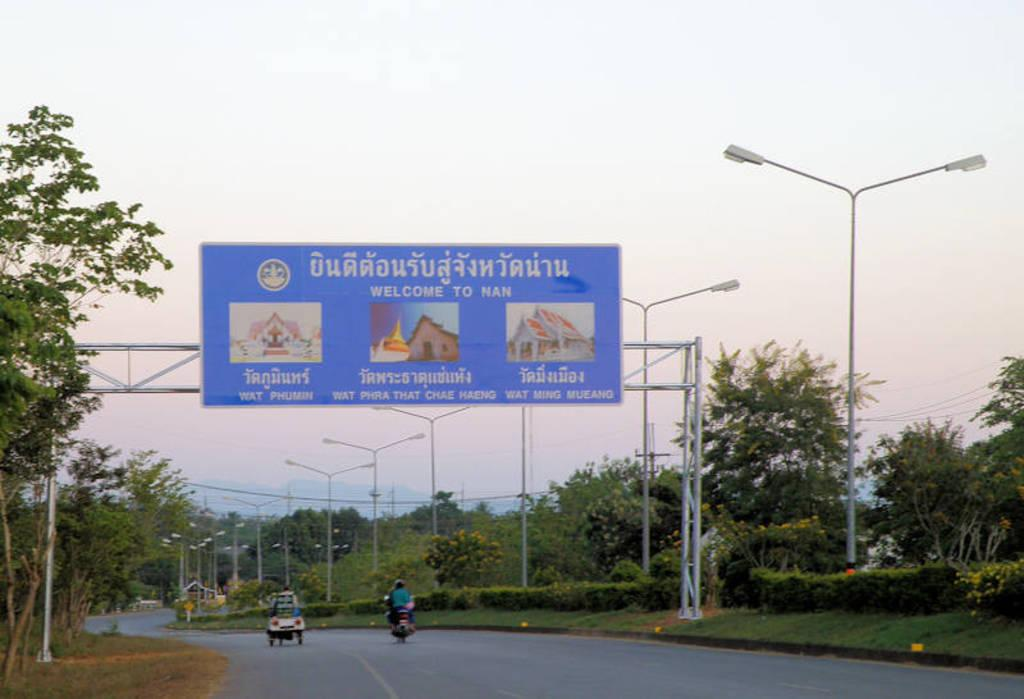<image>
Render a clear and concise summary of the photo. A blue sign over the road says welcome to Nan. 